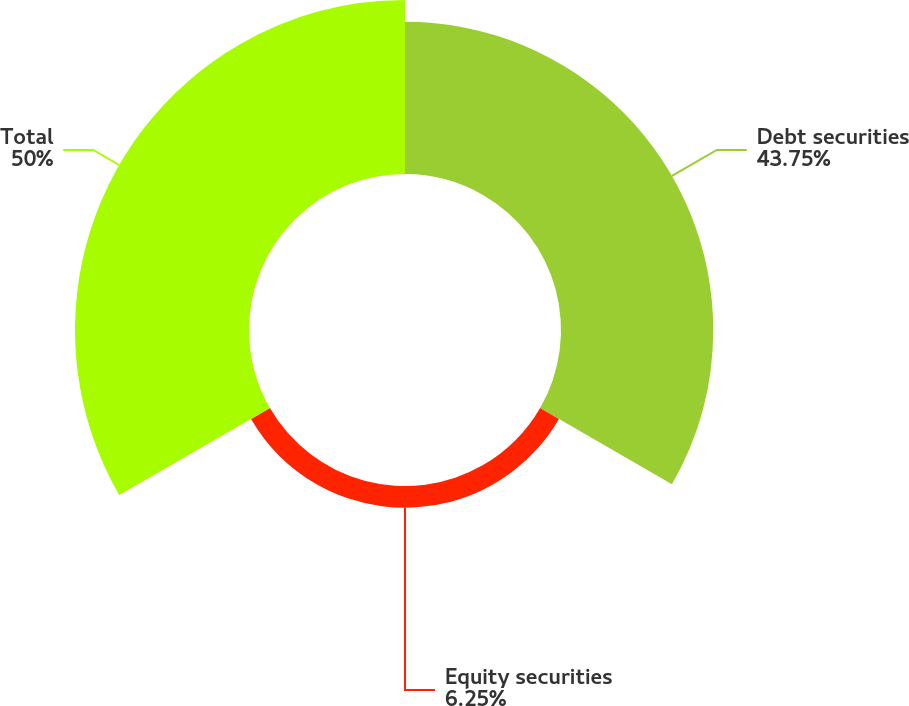Convert chart to OTSL. <chart><loc_0><loc_0><loc_500><loc_500><pie_chart><fcel>Debt securities<fcel>Equity securities<fcel>Total<nl><fcel>43.75%<fcel>6.25%<fcel>50.0%<nl></chart> 